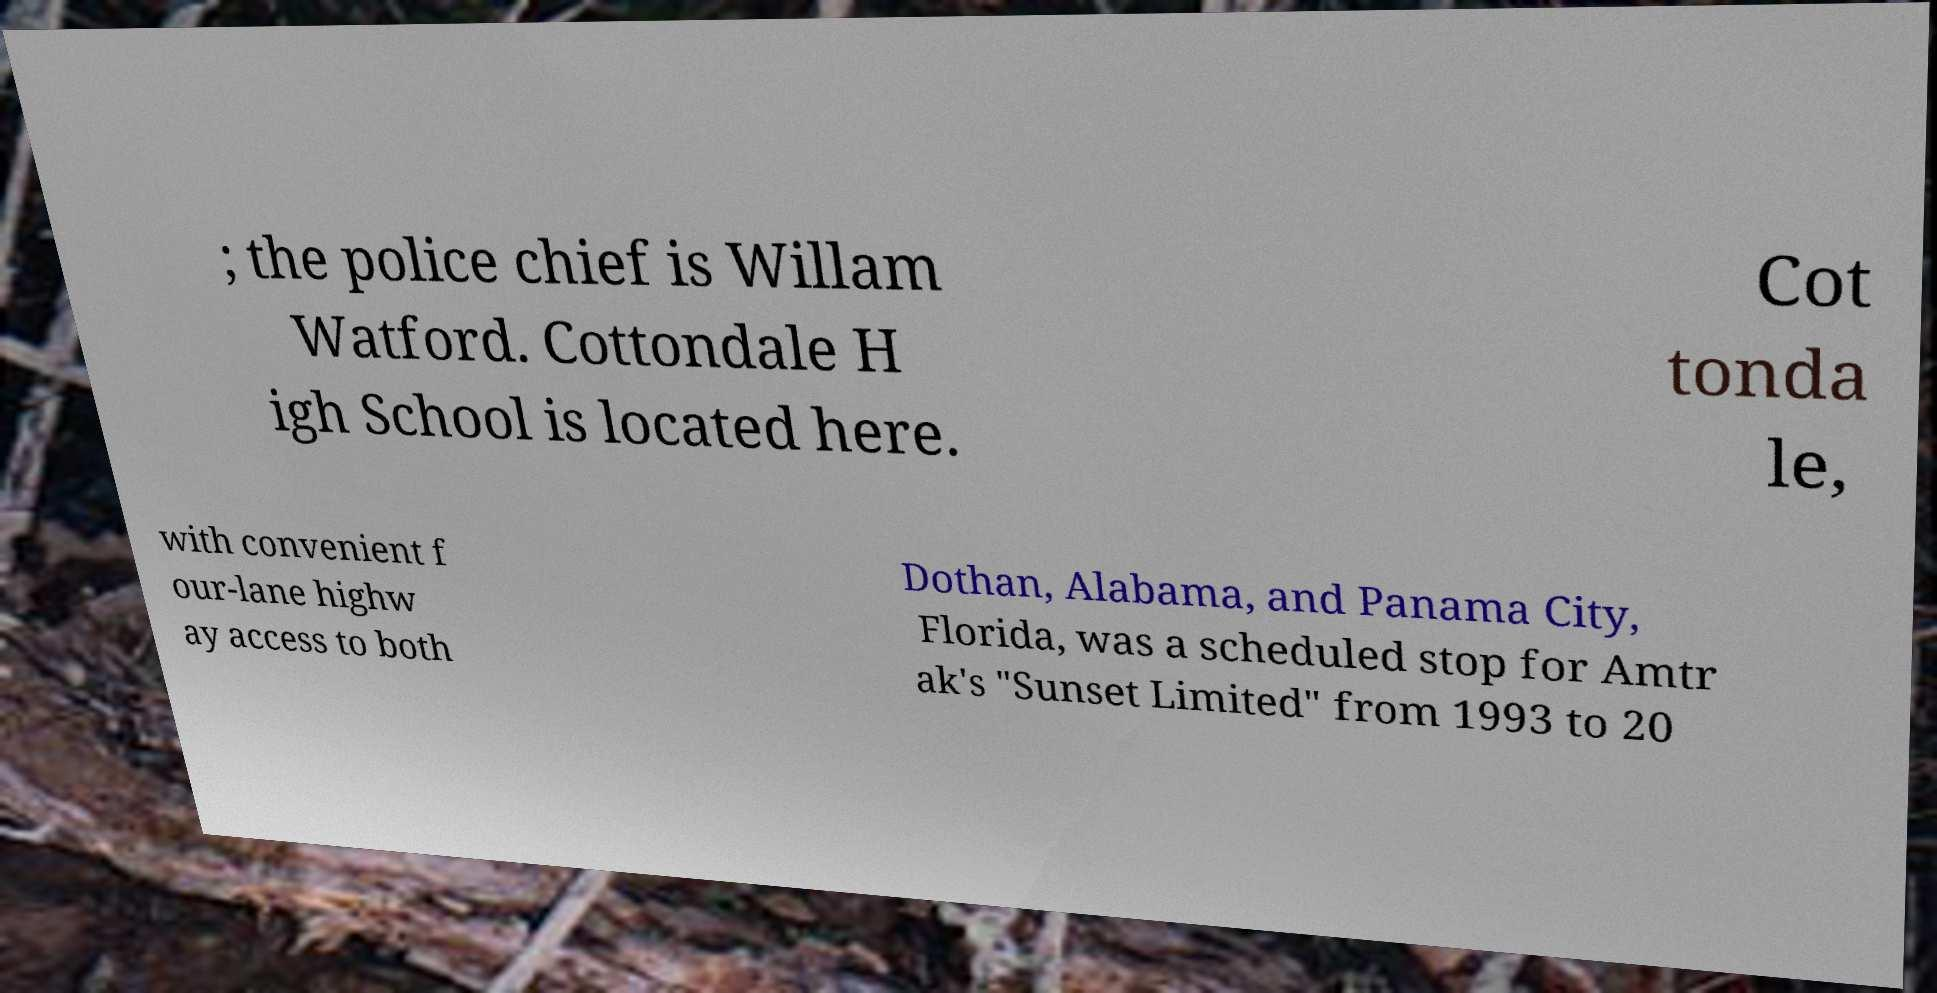Please identify and transcribe the text found in this image. ; the police chief is Willam Watford. Cottondale H igh School is located here. Cot tonda le, with convenient f our-lane highw ay access to both Dothan, Alabama, and Panama City, Florida, was a scheduled stop for Amtr ak's "Sunset Limited" from 1993 to 20 